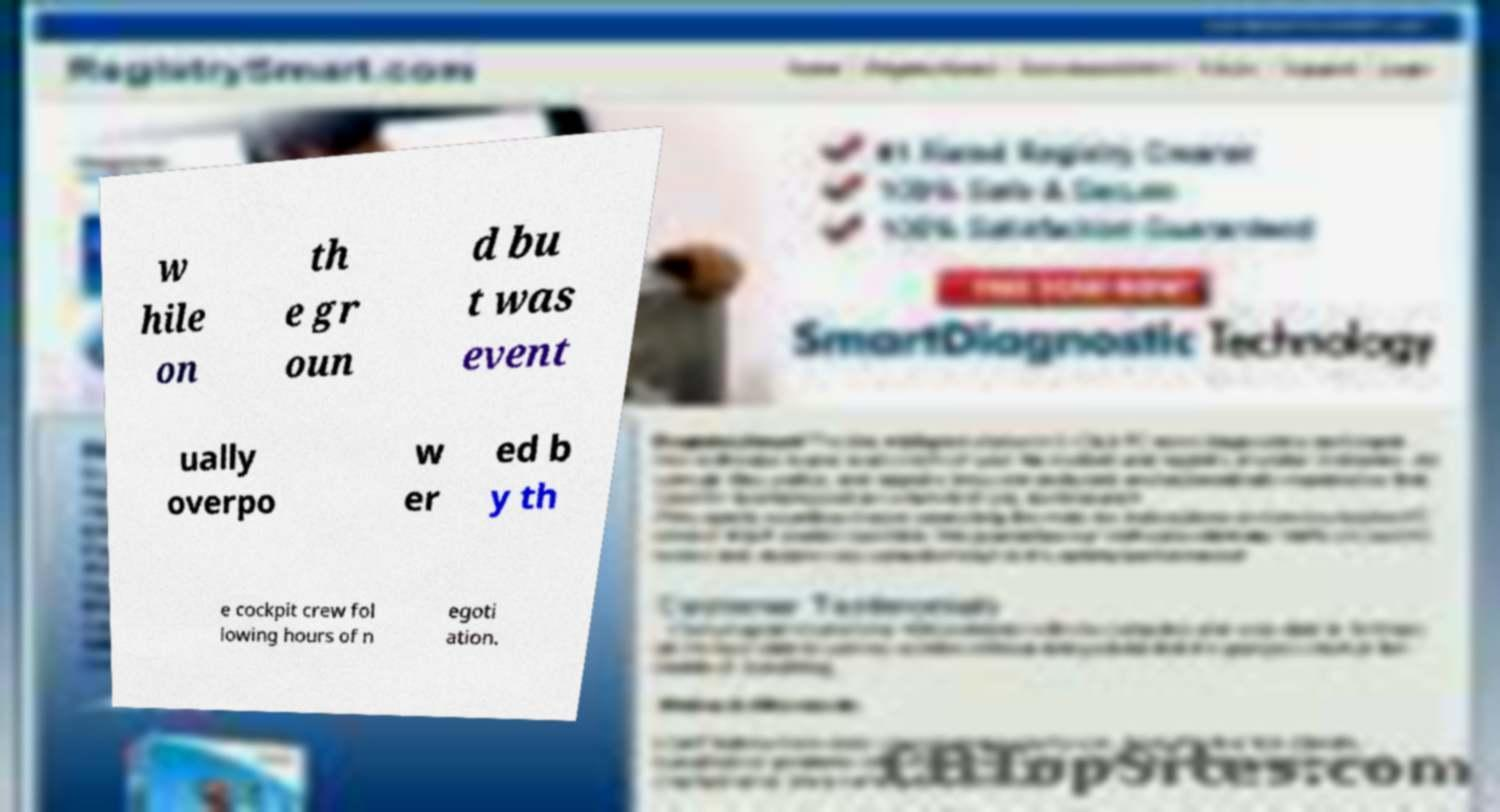Please read and relay the text visible in this image. What does it say? w hile on th e gr oun d bu t was event ually overpo w er ed b y th e cockpit crew fol lowing hours of n egoti ation. 